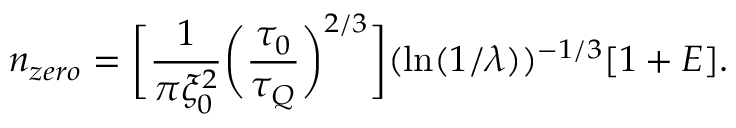<formula> <loc_0><loc_0><loc_500><loc_500>n _ { z e r o } = \left [ \frac { 1 } { \pi \xi _ { 0 } ^ { 2 } } \left ( \frac { \tau _ { 0 } } { \tau _ { Q } } \right ) ^ { 2 / 3 } \right ] ( \ln ( 1 / \lambda ) ) ^ { - 1 / 3 } [ 1 + E ] .</formula> 